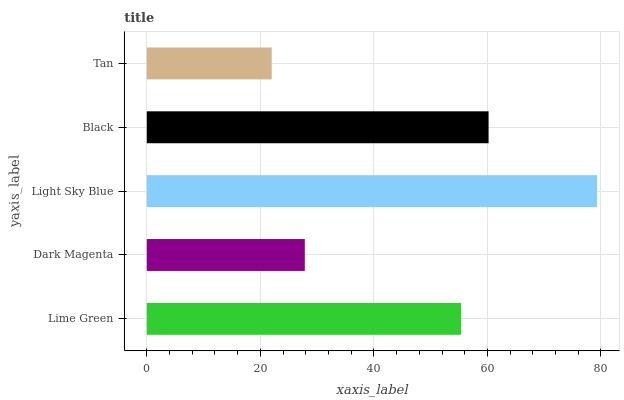Is Tan the minimum?
Answer yes or no. Yes. Is Light Sky Blue the maximum?
Answer yes or no. Yes. Is Dark Magenta the minimum?
Answer yes or no. No. Is Dark Magenta the maximum?
Answer yes or no. No. Is Lime Green greater than Dark Magenta?
Answer yes or no. Yes. Is Dark Magenta less than Lime Green?
Answer yes or no. Yes. Is Dark Magenta greater than Lime Green?
Answer yes or no. No. Is Lime Green less than Dark Magenta?
Answer yes or no. No. Is Lime Green the high median?
Answer yes or no. Yes. Is Lime Green the low median?
Answer yes or no. Yes. Is Light Sky Blue the high median?
Answer yes or no. No. Is Black the low median?
Answer yes or no. No. 